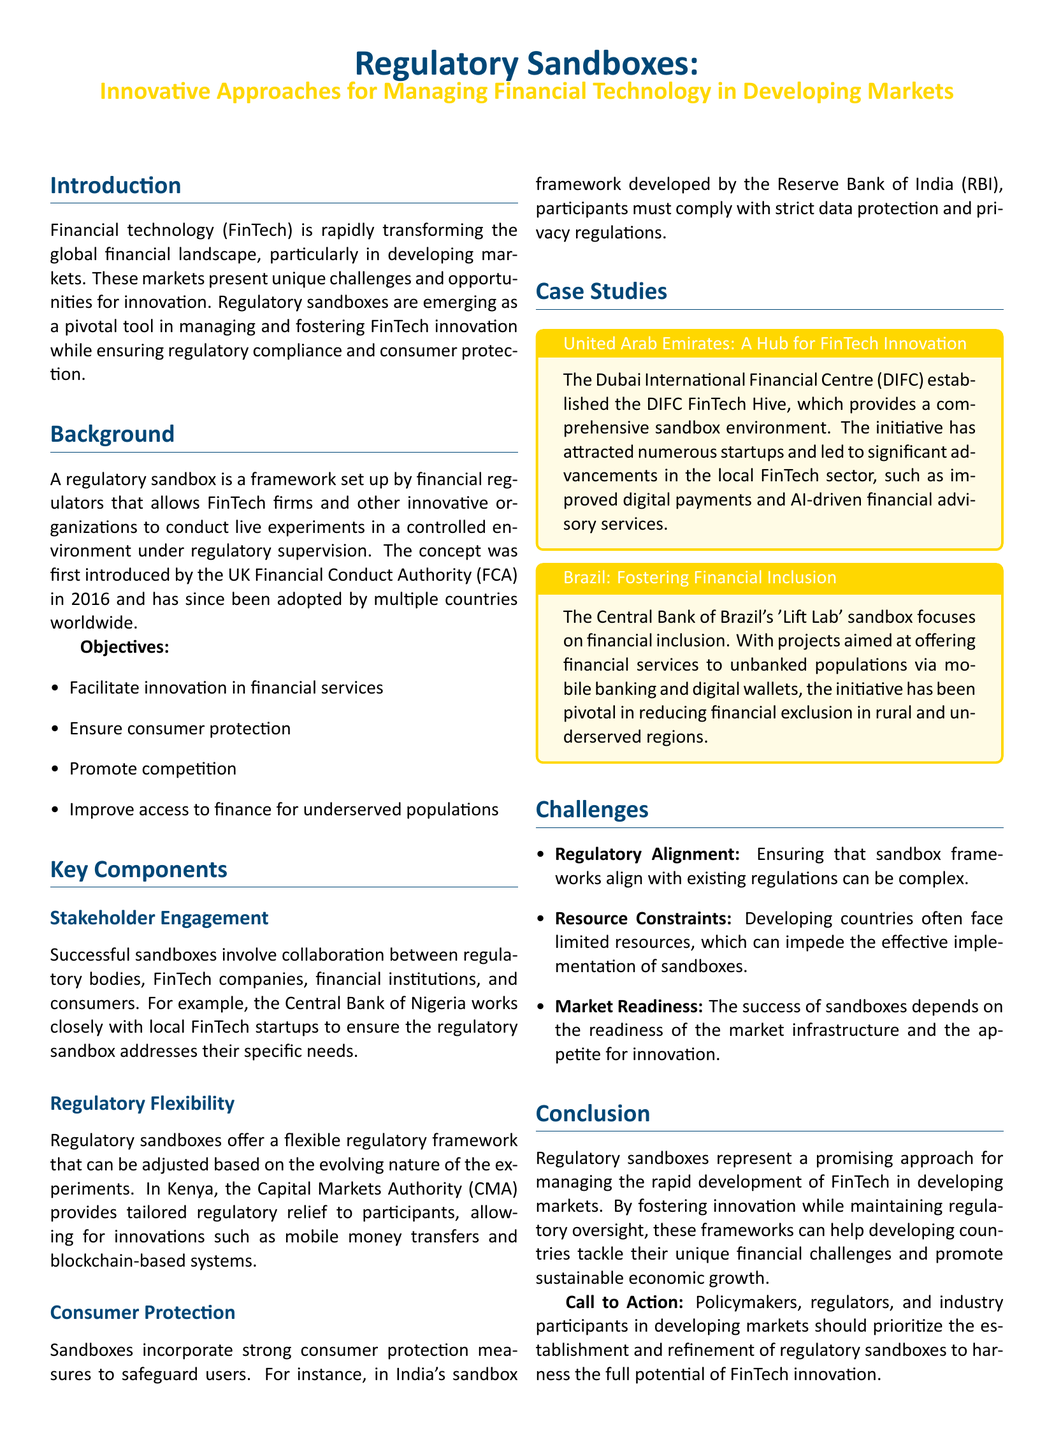What is the primary focus of regulatory sandboxes? The document indicates that regulatory sandboxes primarily focus on managing and fostering FinTech innovation while ensuring regulatory compliance and consumer protection.
Answer: FinTech innovation What year was the concept of regulatory sandboxes first introduced? The introduction section states that the concept of regulatory sandboxes was first introduced by the UK Financial Conduct Authority in 2016.
Answer: 2016 Which country's central bank collaborates with local FinTech startups? The section on stakeholder engagement mentions the Central Bank of Nigeria's collaboration with local FinTech startups.
Answer: Nigeria What is one objective of regulatory sandboxes mentioned in the document? The objectives listed in the document include improving access to finance for underserved populations.
Answer: Improve access to finance What major challenge associated with regulatory sandboxes is mentioned? The section on challenges identifies regulatory alignment as a complex issue that needs to be addressed in developing markets.
Answer: Regulatory alignment What initiative is associated with the United Arab Emirates in the case studies? The case studies reference the Dubai International Financial Centre establishing the DIFC FinTech Hive.
Answer: DIFC FinTech Hive What does Brazil's 'Lift Lab' sandbox aim to address? The case studies state that Brazil's ‘Lift Lab’ sandbox focuses on reducing financial exclusion in rural and underserved regions.
Answer: Financial exclusion How do regulatory sandboxes contribute to consumer protection? The document explains that regulatory sandboxes incorporate strong consumer protection measures to safeguard users.
Answer: Strong consumer protection measures What should policymakers and regulators prioritize according to the conclusion? The conclusion emphasizes that policymakers, regulators, and industry participants should prioritize the establishment and refinement of regulatory sandboxes.
Answer: Establishment and refinement of sandboxes 